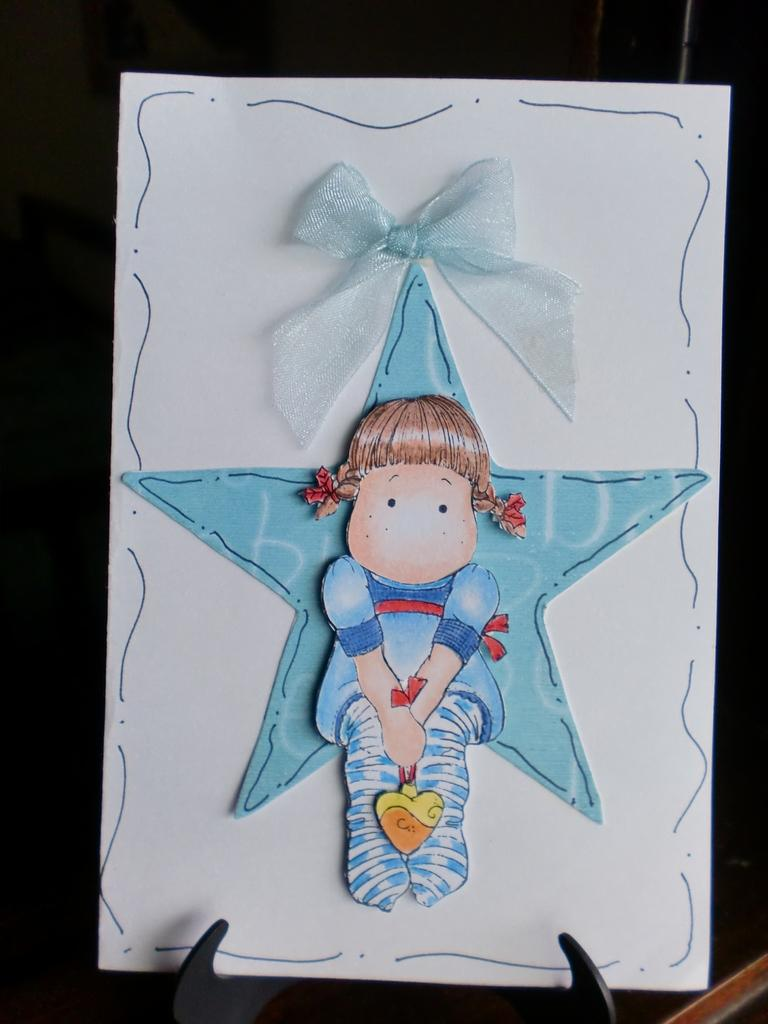What is the main object in the image? There is a board in the image. How is the board positioned in the image? The board is on a strand. What is attached to the board? There is a ribbon on the board. What can be seen on the board? There is a picture on the board. What type of machine is depicted in the picture on the board? There is no machine depicted in the picture on the board; it is not mentioned in the facts provided. 